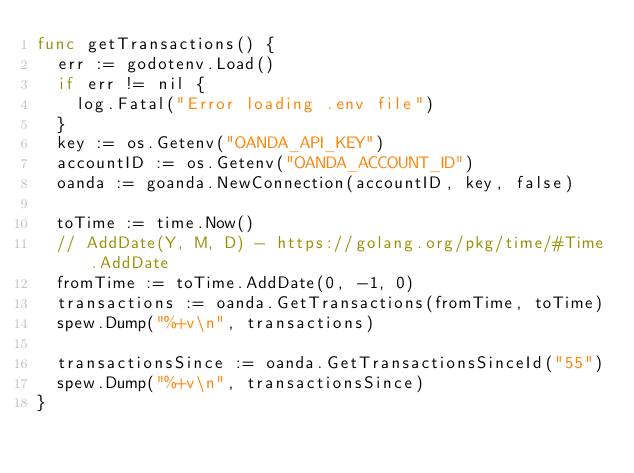<code> <loc_0><loc_0><loc_500><loc_500><_Go_>func getTransactions() {
	err := godotenv.Load()
	if err != nil {
		log.Fatal("Error loading .env file")
	}
	key := os.Getenv("OANDA_API_KEY")
	accountID := os.Getenv("OANDA_ACCOUNT_ID")
	oanda := goanda.NewConnection(accountID, key, false)

	toTime := time.Now()
	// AddDate(Y, M, D) - https://golang.org/pkg/time/#Time.AddDate
	fromTime := toTime.AddDate(0, -1, 0)
	transactions := oanda.GetTransactions(fromTime, toTime)
	spew.Dump("%+v\n", transactions)

	transactionsSince := oanda.GetTransactionsSinceId("55")
	spew.Dump("%+v\n", transactionsSince)
}
</code> 